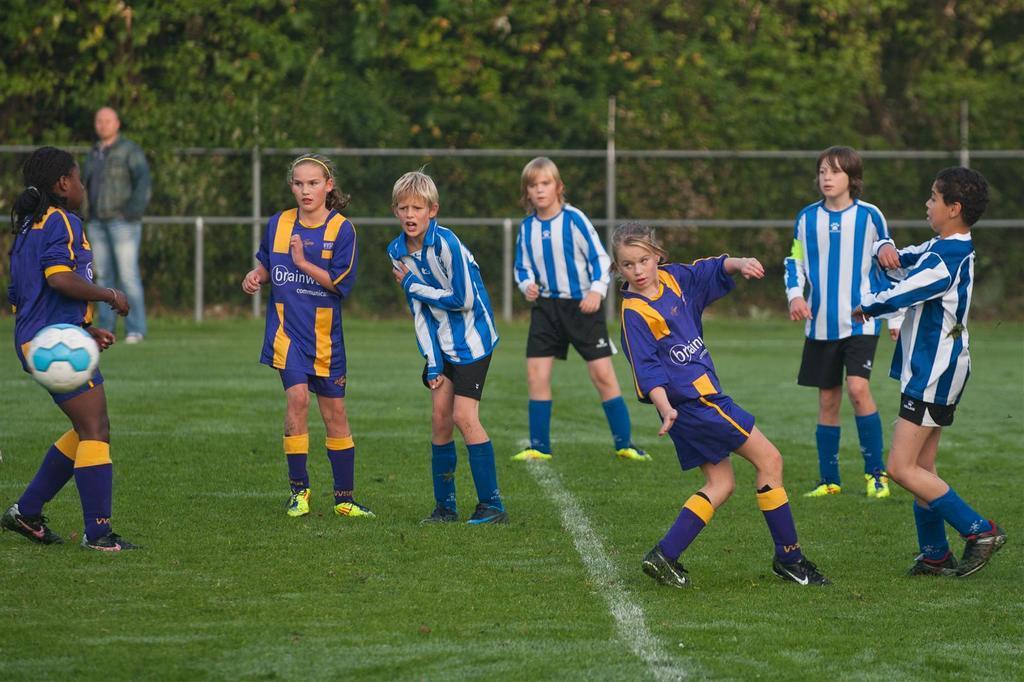Could you give a brief overview of what you see in this image? In this picture there are kids and we can see grass and ball in the air. In the background of the image there is a man standing and we can see fence and trees. 